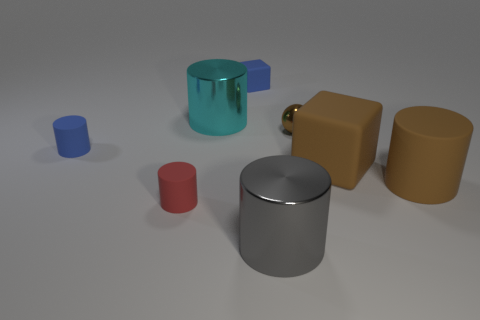Add 2 yellow things. How many objects exist? 10 Subtract all rubber cylinders. How many cylinders are left? 2 Subtract all small brown shiny objects. Subtract all big brown cylinders. How many objects are left? 6 Add 5 red cylinders. How many red cylinders are left? 6 Add 3 large gray matte cylinders. How many large gray matte cylinders exist? 3 Subtract all red cylinders. How many cylinders are left? 4 Subtract 1 brown cylinders. How many objects are left? 7 Subtract all cylinders. How many objects are left? 3 Subtract 2 cubes. How many cubes are left? 0 Subtract all green blocks. Subtract all blue cylinders. How many blocks are left? 2 